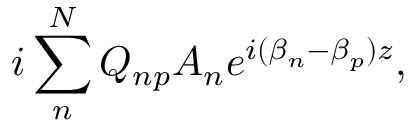<formula> <loc_0><loc_0><loc_500><loc_500>i \sum _ { n } ^ { N } Q _ { n p } A _ { n } e ^ { i ( \beta _ { n } - \beta _ { p } ) z } ,</formula> 